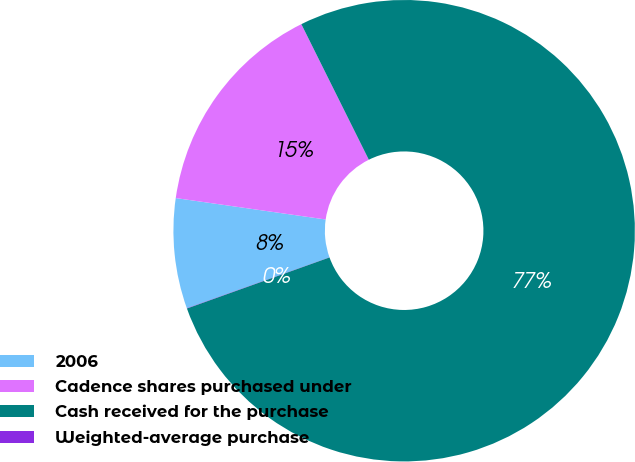Convert chart. <chart><loc_0><loc_0><loc_500><loc_500><pie_chart><fcel>2006<fcel>Cadence shares purchased under<fcel>Cash received for the purchase<fcel>Weighted-average purchase<nl><fcel>7.71%<fcel>15.39%<fcel>76.88%<fcel>0.02%<nl></chart> 